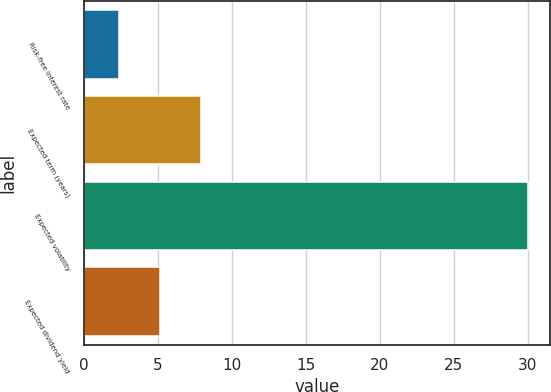<chart> <loc_0><loc_0><loc_500><loc_500><bar_chart><fcel>Risk-free interest rate<fcel>Expected term (years)<fcel>Expected volatility<fcel>Expected dividend yield<nl><fcel>2.4<fcel>7.92<fcel>30<fcel>5.16<nl></chart> 